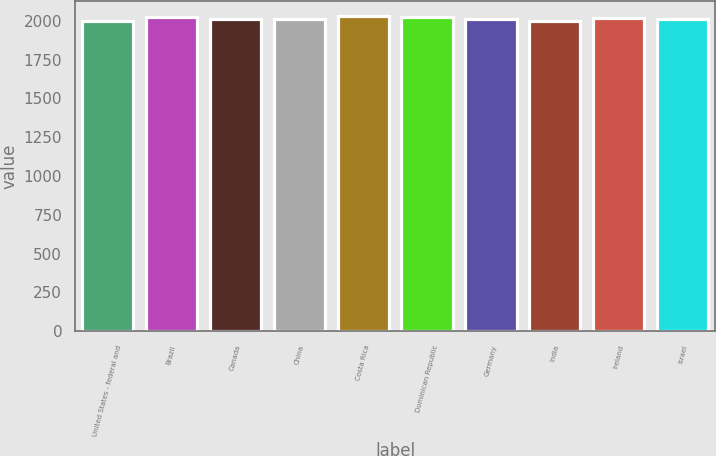Convert chart. <chart><loc_0><loc_0><loc_500><loc_500><bar_chart><fcel>United States - federal and<fcel>Brazil<fcel>Canada<fcel>China<fcel>Costa Rica<fcel>Dominican Republic<fcel>Germany<fcel>India<fcel>Ireland<fcel>Israel<nl><fcel>1998<fcel>2021.6<fcel>2010.8<fcel>2009<fcel>2028.8<fcel>2023.4<fcel>2012.6<fcel>2002<fcel>2018<fcel>2014.4<nl></chart> 